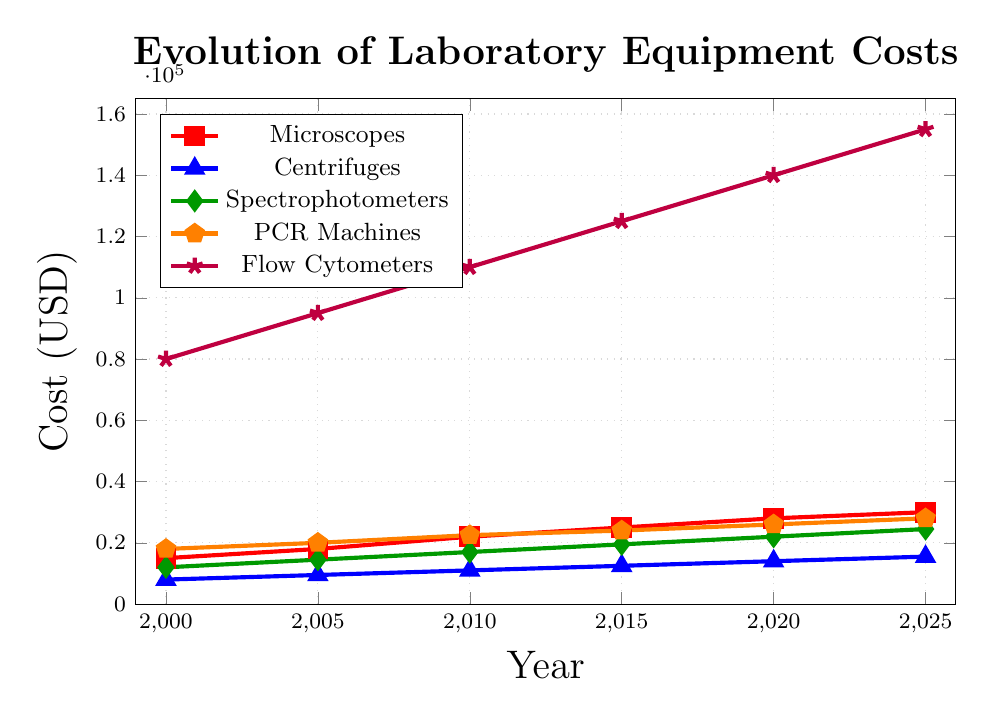What is the cost of Microscopes in 2025? Find the point on the red line corresponding to the year 2025 and read the value on the y-axis.
Answer: 30000 Which type of equipment had the highest cost in 2000? Compare the y-values for all types of equipment at the year 2000. The one with the highest value is the answer. Flow Cytometers had the highest y-value.
Answer: Flow Cytometers How much did the cost of Centrifuges increase between 2000 and 2025? Find the y-values of Centrifuges at 2000 and 2025. Subtract the value at 2000 from the value at 2025: 15500 - 8000 = 7500.
Answer: 7500 Which piece of equipment had the fastest increase in cost from 2000 to 2025? Calculate the increase in cost for each equipment type from 2000 to 2025 and compare. Flow Cytometers increased the most (155000 - 80000 = 75000).
Answer: Flow Cytometers What is the average cost of PCR Machines over all the years? Sum the values of PCR Machines over all years and divide by the number of years: (18000 + 20000 + 22500 + 24000 + 26000 + 28000) / 6.
Answer: 23166.67 Between which two years did Spectrophotometers show the greatest increase in cost? Calculate the differences in cost for Spectrophotometers between each adjacent pair of years and compare. The greatest increase is between 2005 and 2010 (17000 - 14500 = 2500).
Answer: 2005 and 2010 In 2015, which equipment had the lowest cost? Compare the y-values for all types of equipment at the year 2015. Centrifuges had the lowest y-value.
Answer: Centrifuges What is the difference in cost between Microscopes and PCR Machines in 2020? Find the y-values of Microscopes and PCR Machines at the year 2020 and subtract the cost of Microscopes from that of PCR Machines: 26000 - 28000 = 2000.
Answer: 2000 By how much did the cost of Flow Cytometers increase from 2000 to 2010? Find the y-values of Flow Cytometers at 2000 and 2010. Subtract the value at 2000 from the value at 2010: 110000 - 80000 = 30000.
Answer: 30000 In which year did the costs of Spectrophotometers and Centrifuges diverge the most? Calculate the absolute differences in costs between Spectrophotometers and Centrifuges for each year and identify the maximum value. The most significant divergence occurs in 2025 (24500 - 15500 = 9000).
Answer: 2025 